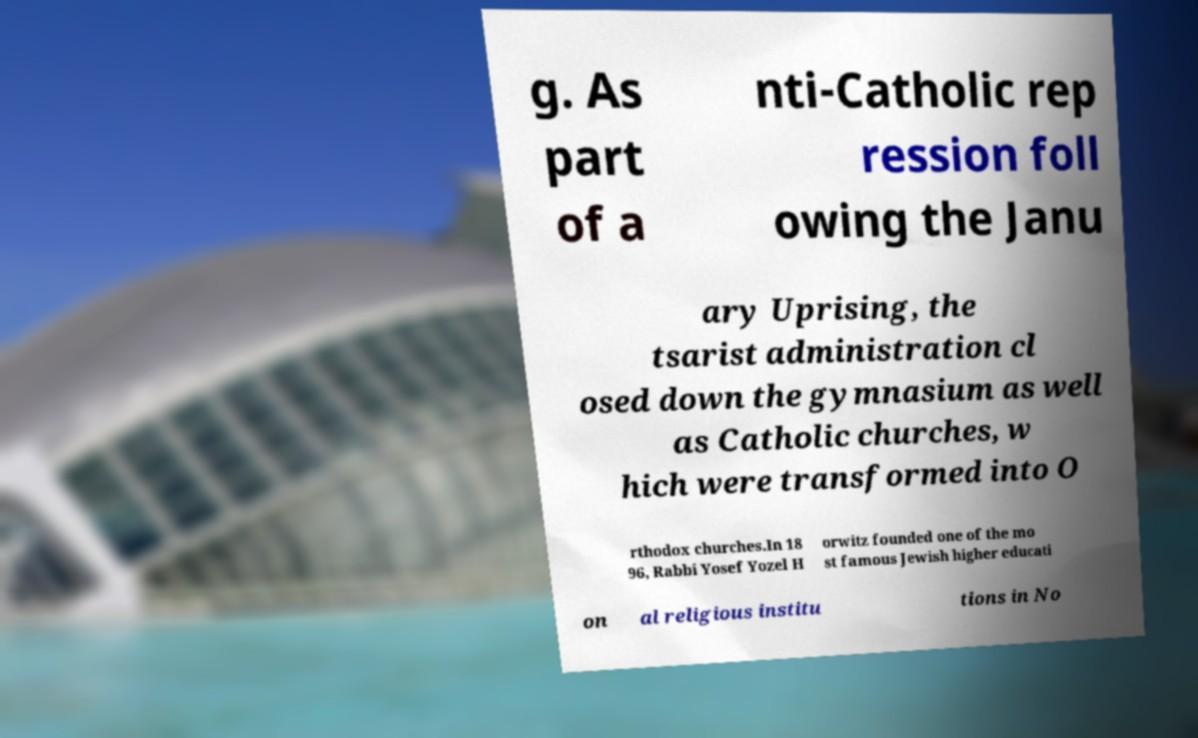Could you extract and type out the text from this image? g. As part of a nti-Catholic rep ression foll owing the Janu ary Uprising, the tsarist administration cl osed down the gymnasium as well as Catholic churches, w hich were transformed into O rthodox churches.In 18 96, Rabbi Yosef Yozel H orwitz founded one of the mo st famous Jewish higher educati on al religious institu tions in No 